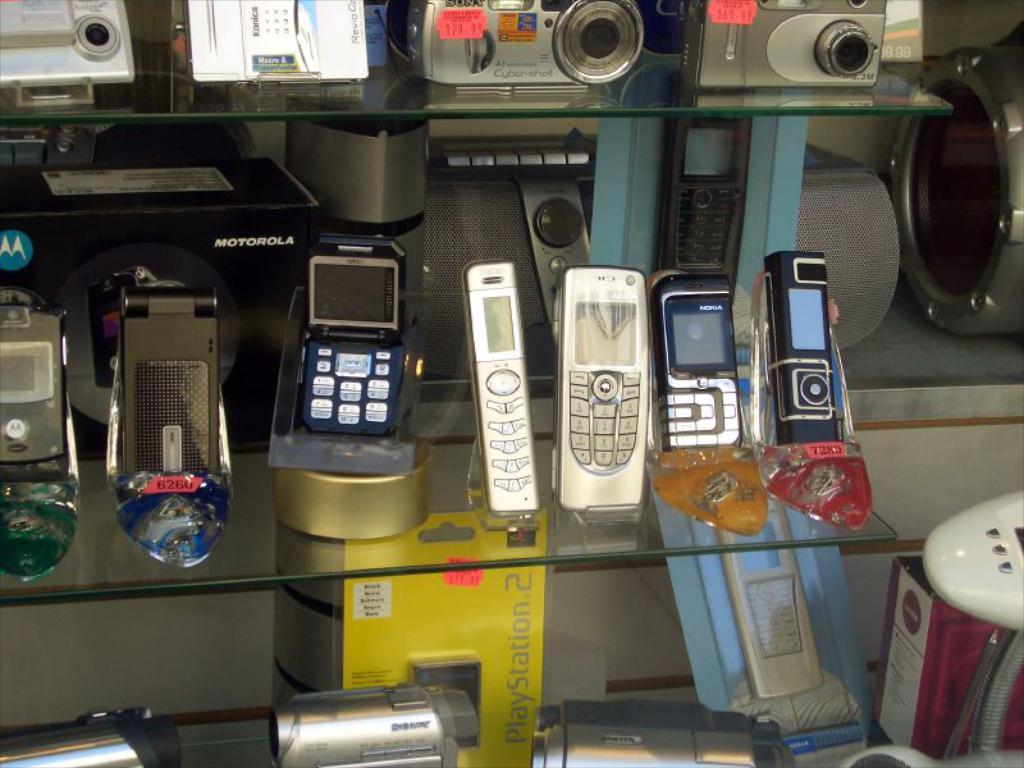What brand is displayed in the background?
Give a very brief answer. Motorola. Which brand phone is featured in the black box?
Give a very brief answer. Motorola. 